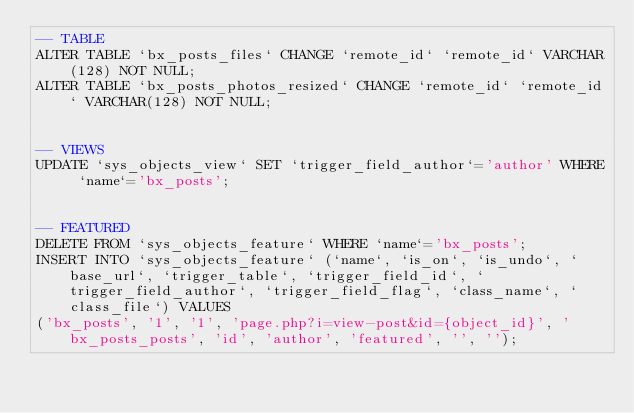Convert code to text. <code><loc_0><loc_0><loc_500><loc_500><_SQL_>-- TABLE
ALTER TABLE `bx_posts_files` CHANGE `remote_id` `remote_id` VARCHAR(128) NOT NULL;
ALTER TABLE `bx_posts_photos_resized` CHANGE `remote_id` `remote_id` VARCHAR(128) NOT NULL;


-- VIEWS
UPDATE `sys_objects_view` SET `trigger_field_author`='author' WHERE `name`='bx_posts';


-- FEATURED
DELETE FROM `sys_objects_feature` WHERE `name`='bx_posts';
INSERT INTO `sys_objects_feature` (`name`, `is_on`, `is_undo`, `base_url`, `trigger_table`, `trigger_field_id`, `trigger_field_author`, `trigger_field_flag`, `class_name`, `class_file`) VALUES 
('bx_posts', '1', '1', 'page.php?i=view-post&id={object_id}', 'bx_posts_posts', 'id', 'author', 'featured', '', '');</code> 